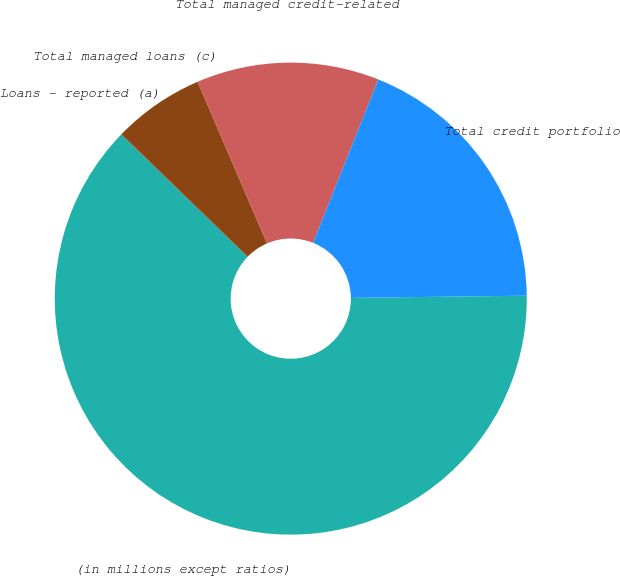<chart> <loc_0><loc_0><loc_500><loc_500><pie_chart><fcel>(in millions except ratios)<fcel>Loans - reported (a)<fcel>Total managed loans (c)<fcel>Total managed credit-related<fcel>Total credit portfolio<nl><fcel>62.43%<fcel>0.03%<fcel>6.27%<fcel>12.51%<fcel>18.75%<nl></chart> 